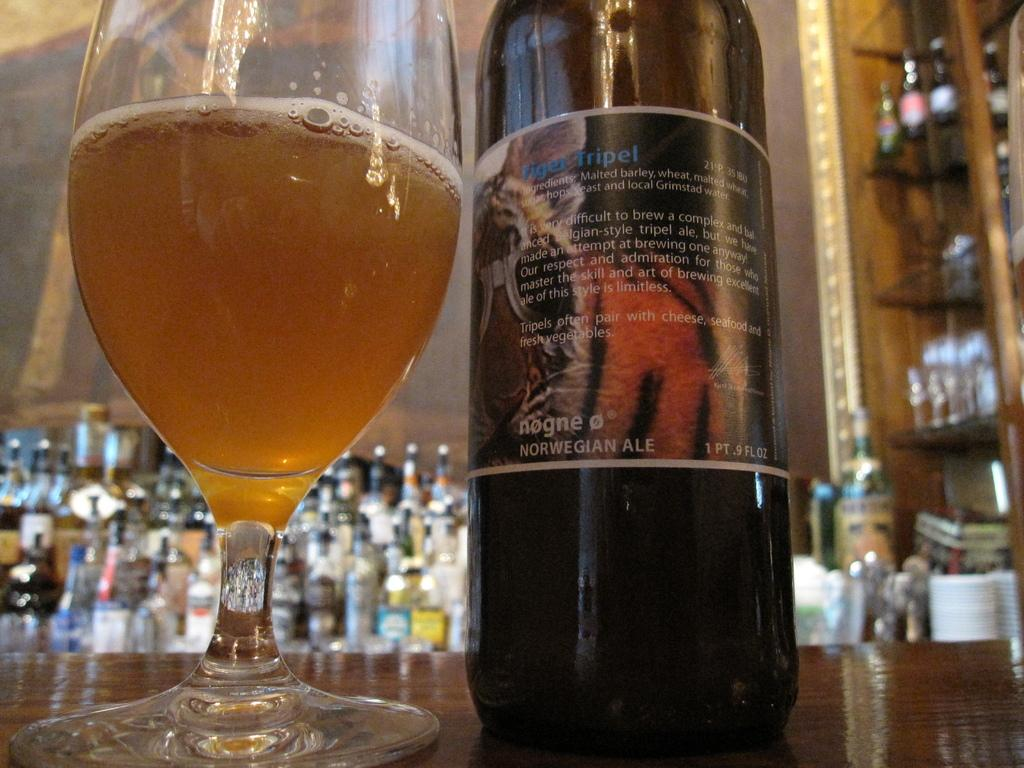<image>
Write a terse but informative summary of the picture. Tiger Tripel is the name printed on the label of this Norwegian Ale. 